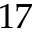Convert formula to latex. <formula><loc_0><loc_0><loc_500><loc_500>1 7</formula> 